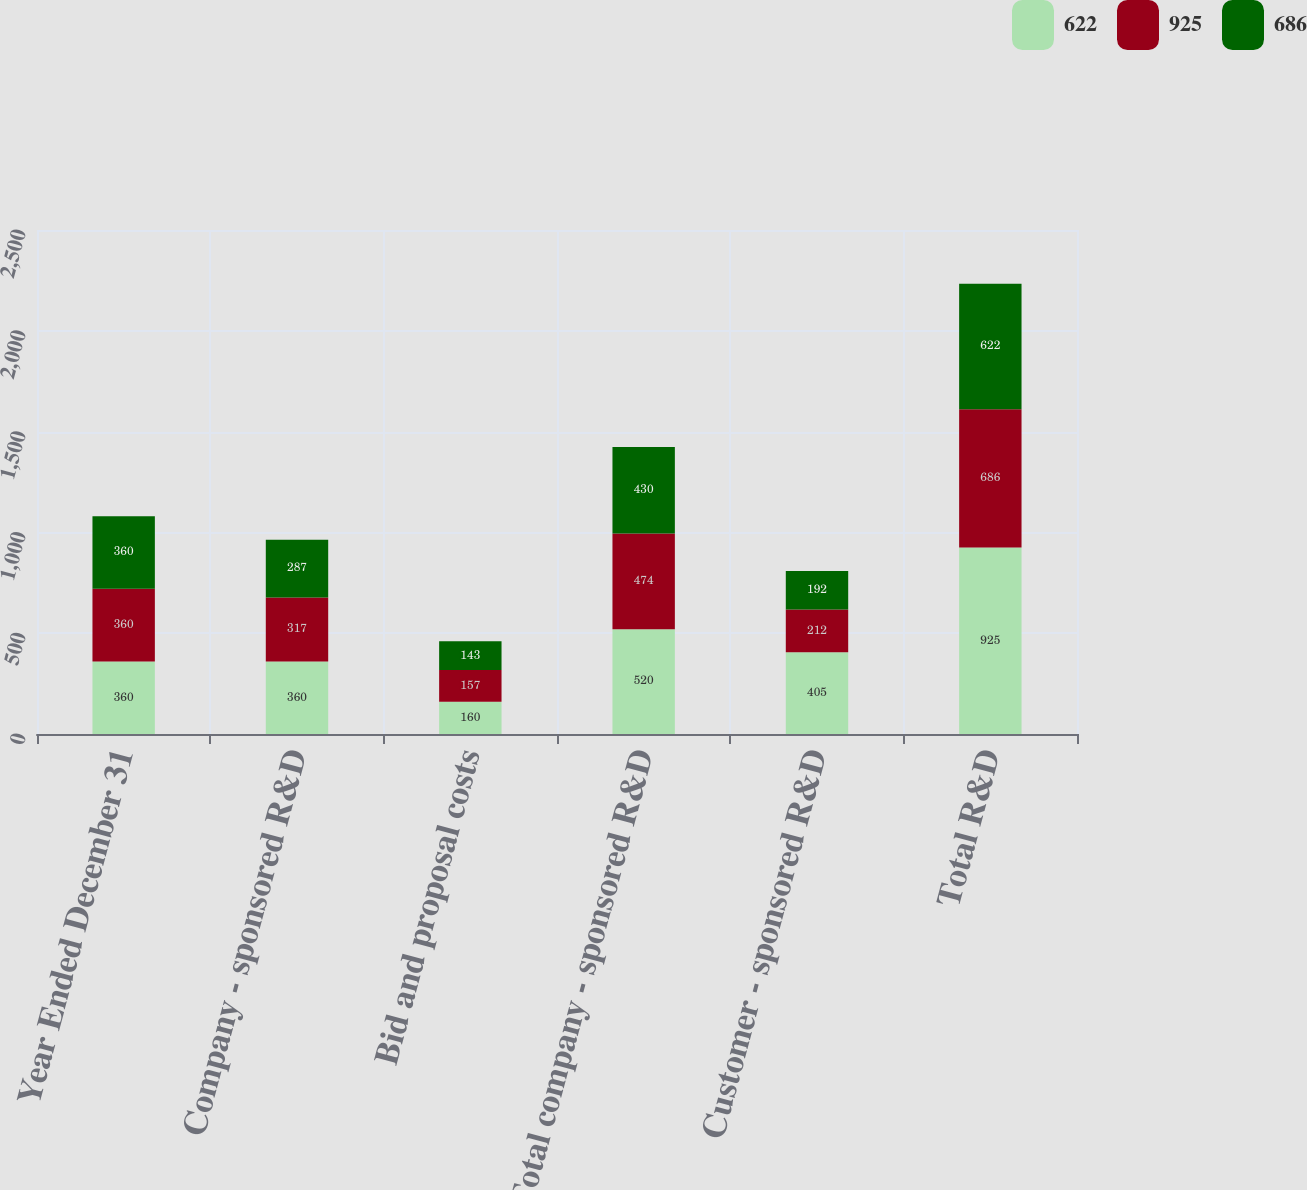<chart> <loc_0><loc_0><loc_500><loc_500><stacked_bar_chart><ecel><fcel>Year Ended December 31<fcel>Company - sponsored R&D<fcel>Bid and proposal costs<fcel>Total company - sponsored R&D<fcel>Customer - sponsored R&D<fcel>Total R&D<nl><fcel>622<fcel>360<fcel>360<fcel>160<fcel>520<fcel>405<fcel>925<nl><fcel>925<fcel>360<fcel>317<fcel>157<fcel>474<fcel>212<fcel>686<nl><fcel>686<fcel>360<fcel>287<fcel>143<fcel>430<fcel>192<fcel>622<nl></chart> 